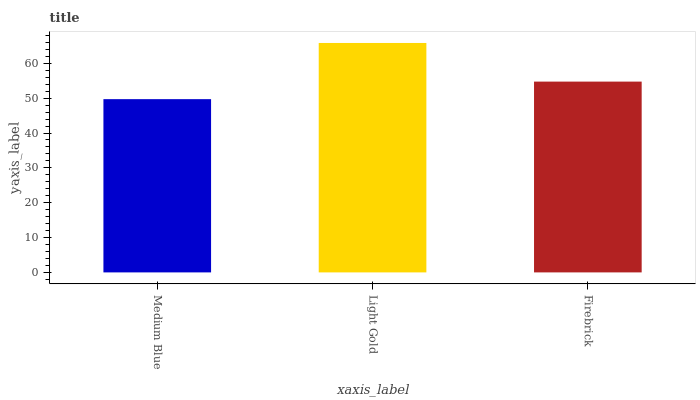Is Medium Blue the minimum?
Answer yes or no. Yes. Is Light Gold the maximum?
Answer yes or no. Yes. Is Firebrick the minimum?
Answer yes or no. No. Is Firebrick the maximum?
Answer yes or no. No. Is Light Gold greater than Firebrick?
Answer yes or no. Yes. Is Firebrick less than Light Gold?
Answer yes or no. Yes. Is Firebrick greater than Light Gold?
Answer yes or no. No. Is Light Gold less than Firebrick?
Answer yes or no. No. Is Firebrick the high median?
Answer yes or no. Yes. Is Firebrick the low median?
Answer yes or no. Yes. Is Medium Blue the high median?
Answer yes or no. No. Is Medium Blue the low median?
Answer yes or no. No. 